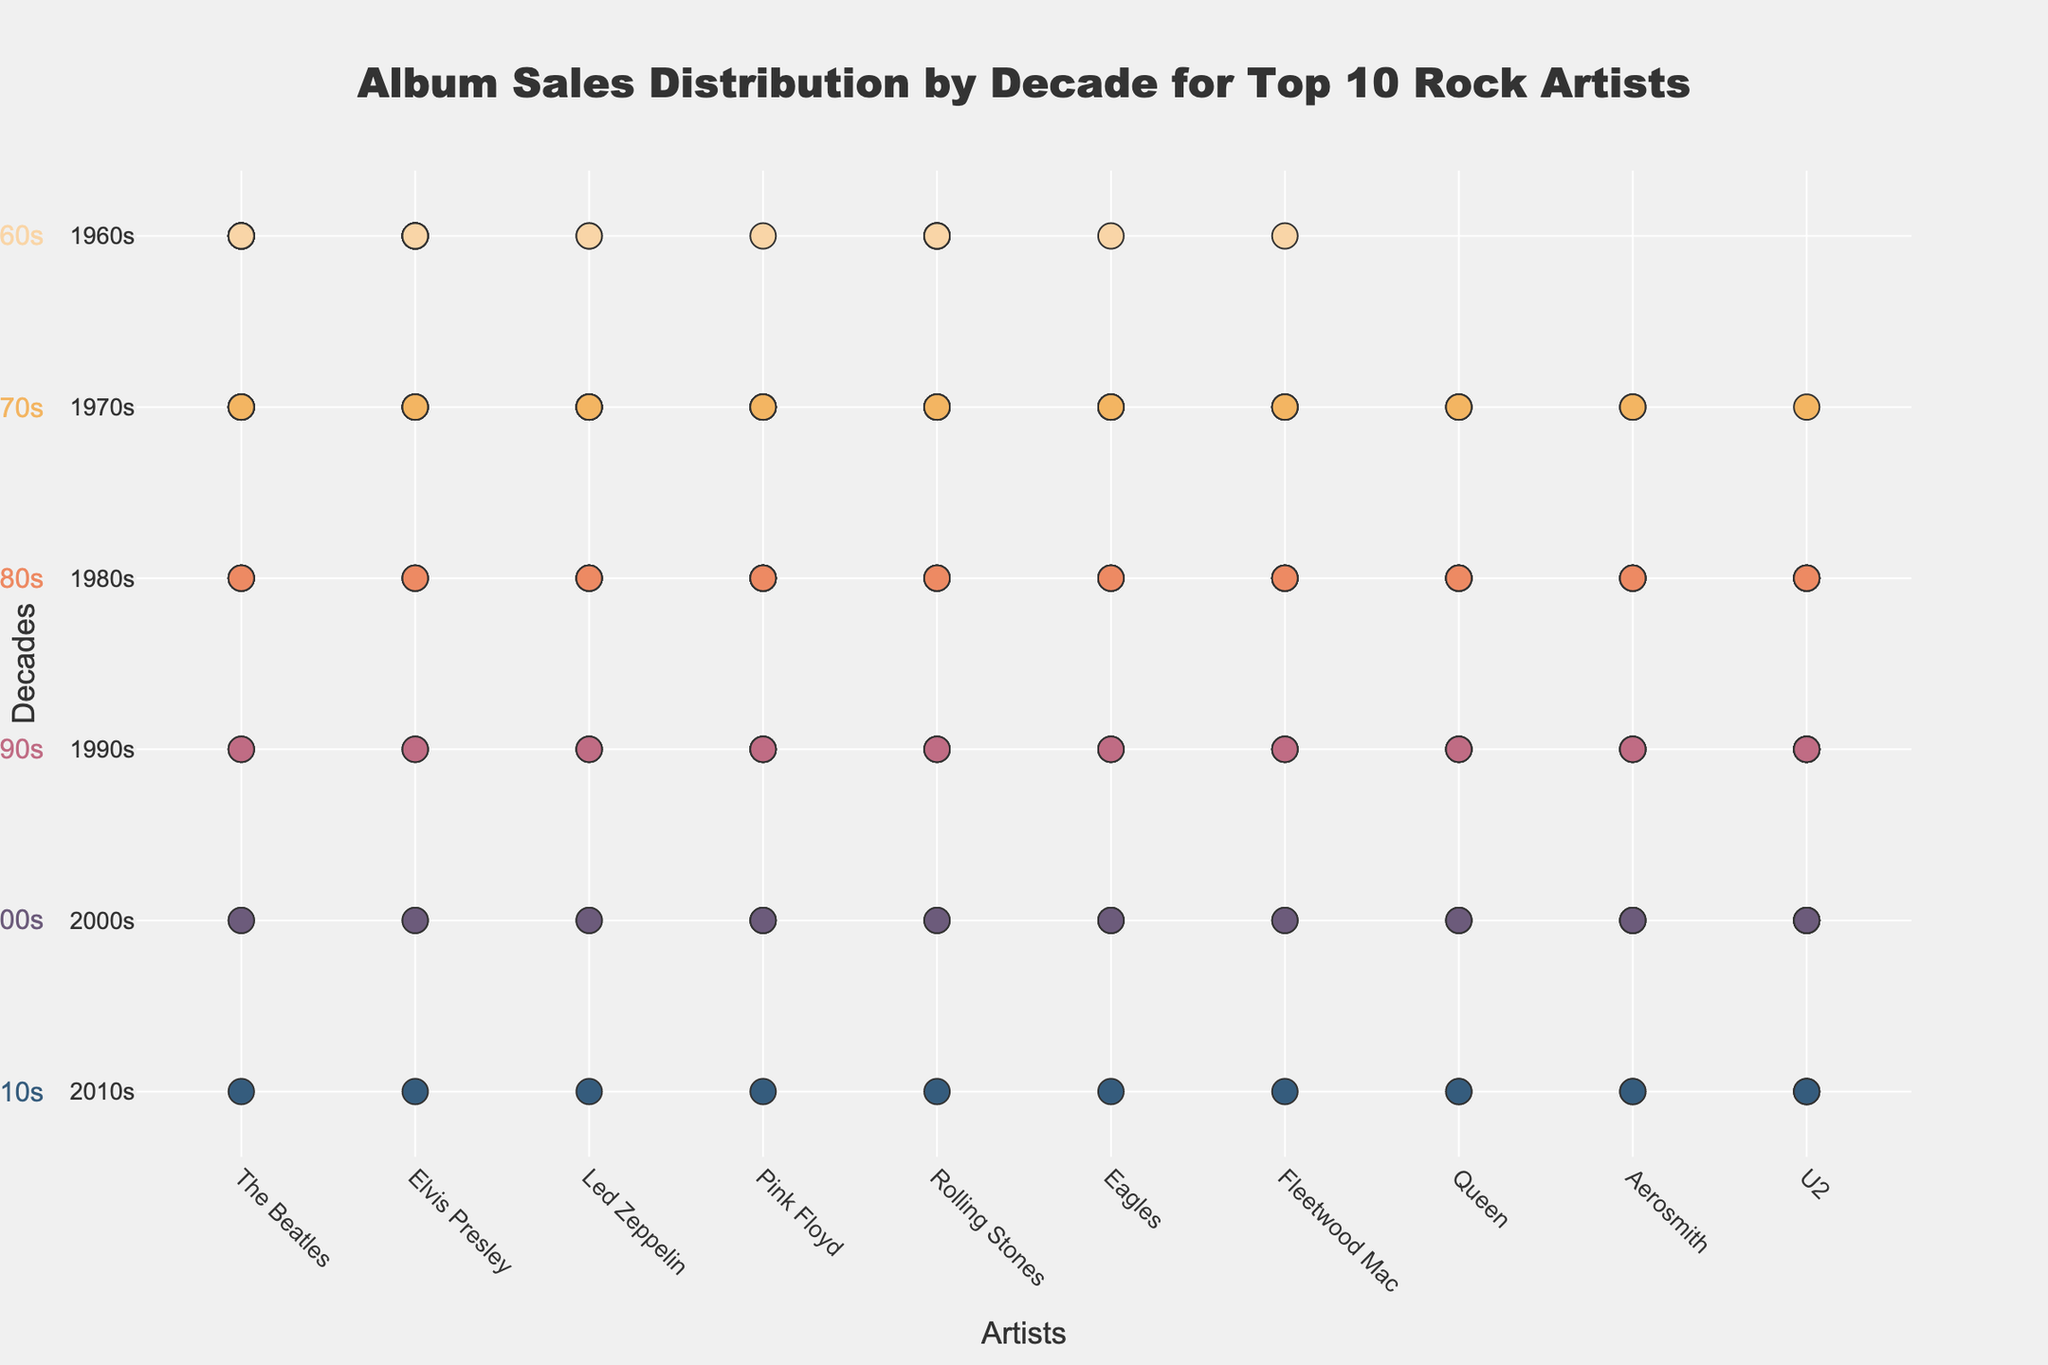What's the title of the figure? The title is usually at the top of the figure. In this case, we see "Album Sales Distribution by Decade for Top 10 Rock Artists" prominently displayed.
Answer: Album Sales Distribution by Decade for Top 10 Rock Artists How many albums did The Beatles sell in the 1970s? The plot shows a series of markers for each decade. For The Beatles in the 1970s, we can count 8 markers.
Answer: 8 Which artist has the most album sales in the 2010s? Look at the bottom row (representing the 2010s) and count the markers for each artist. The artists with the most markers in this row are U2 and Aerosmith, both with 3 markers.
Answer: U2 and Aerosmith How does the album sale for Queen change from the 1980s to the 1990s? For Queen, count the number of markers in the 1980s and the 1990s. In the 1980s, Queen has 7 markers, and in the 1990s, they have 5 markers. The difference is 7 - 5 = 2.
Answer: Decrease by 2 Which artist shows a consistent decrease in album sales across the decades? Examine the trend for each artist. The Beatles, Elvis Presley, and Led Zeppelin show a consistent decrease in album sales as the decades progress.
Answer: The Beatles, Elvis Presley, and Led Zeppelin What are the total album sales of Pink Floyd in the 1990s and 2000s combined? For Pink Floyd, count the markers in the 1990s (5) and the 2000s (3). Summing these, 5 + 3 = 8.
Answer: 8 How many more albums did The Rolling Stones sell in the 1970s compared to the 1960s? Count the markers for The Rolling Stones in the 1970s (7) and 1960s (6). The difference is 7 - 6 = 1.
Answer: 1 Which decade shows the highest overall album sales for all artists combined? Sum the markers for each decade across all artists. The decade with the highest sum will be the 1970s.
Answer: 1970s What's the difference in the number of albums sold by Eagles and Aerosmith in the 1980s? Count the markers for Eagles (5) and Aerosmith (6) in the 1980s. The difference is 6 - 5 = 1.
Answer: 1 In which decade did Fleetwood Mac sell the least number of albums and how many? Look at the row for Fleetwood Mac. The decade with the least number of markers is the 1960s with 1 marker.
Answer: 1960s, 1 